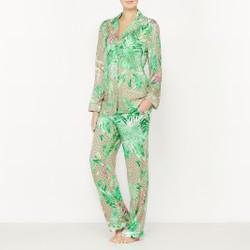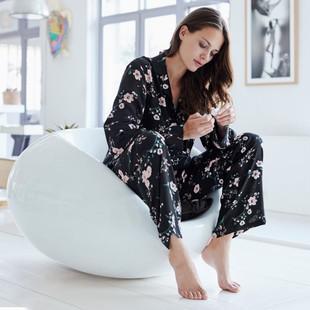The first image is the image on the left, the second image is the image on the right. Examine the images to the left and right. Is the description "One model is wearing purple pajamas and sitting cross-legged on the floor in front of a tufted sofa." accurate? Answer yes or no. No. The first image is the image on the left, the second image is the image on the right. Considering the images on both sides, is "A solid colored pajama set has long pants paired with a long sleeved shirt with contrasting piping on the shirt cuffs and collar." valid? Answer yes or no. No. 